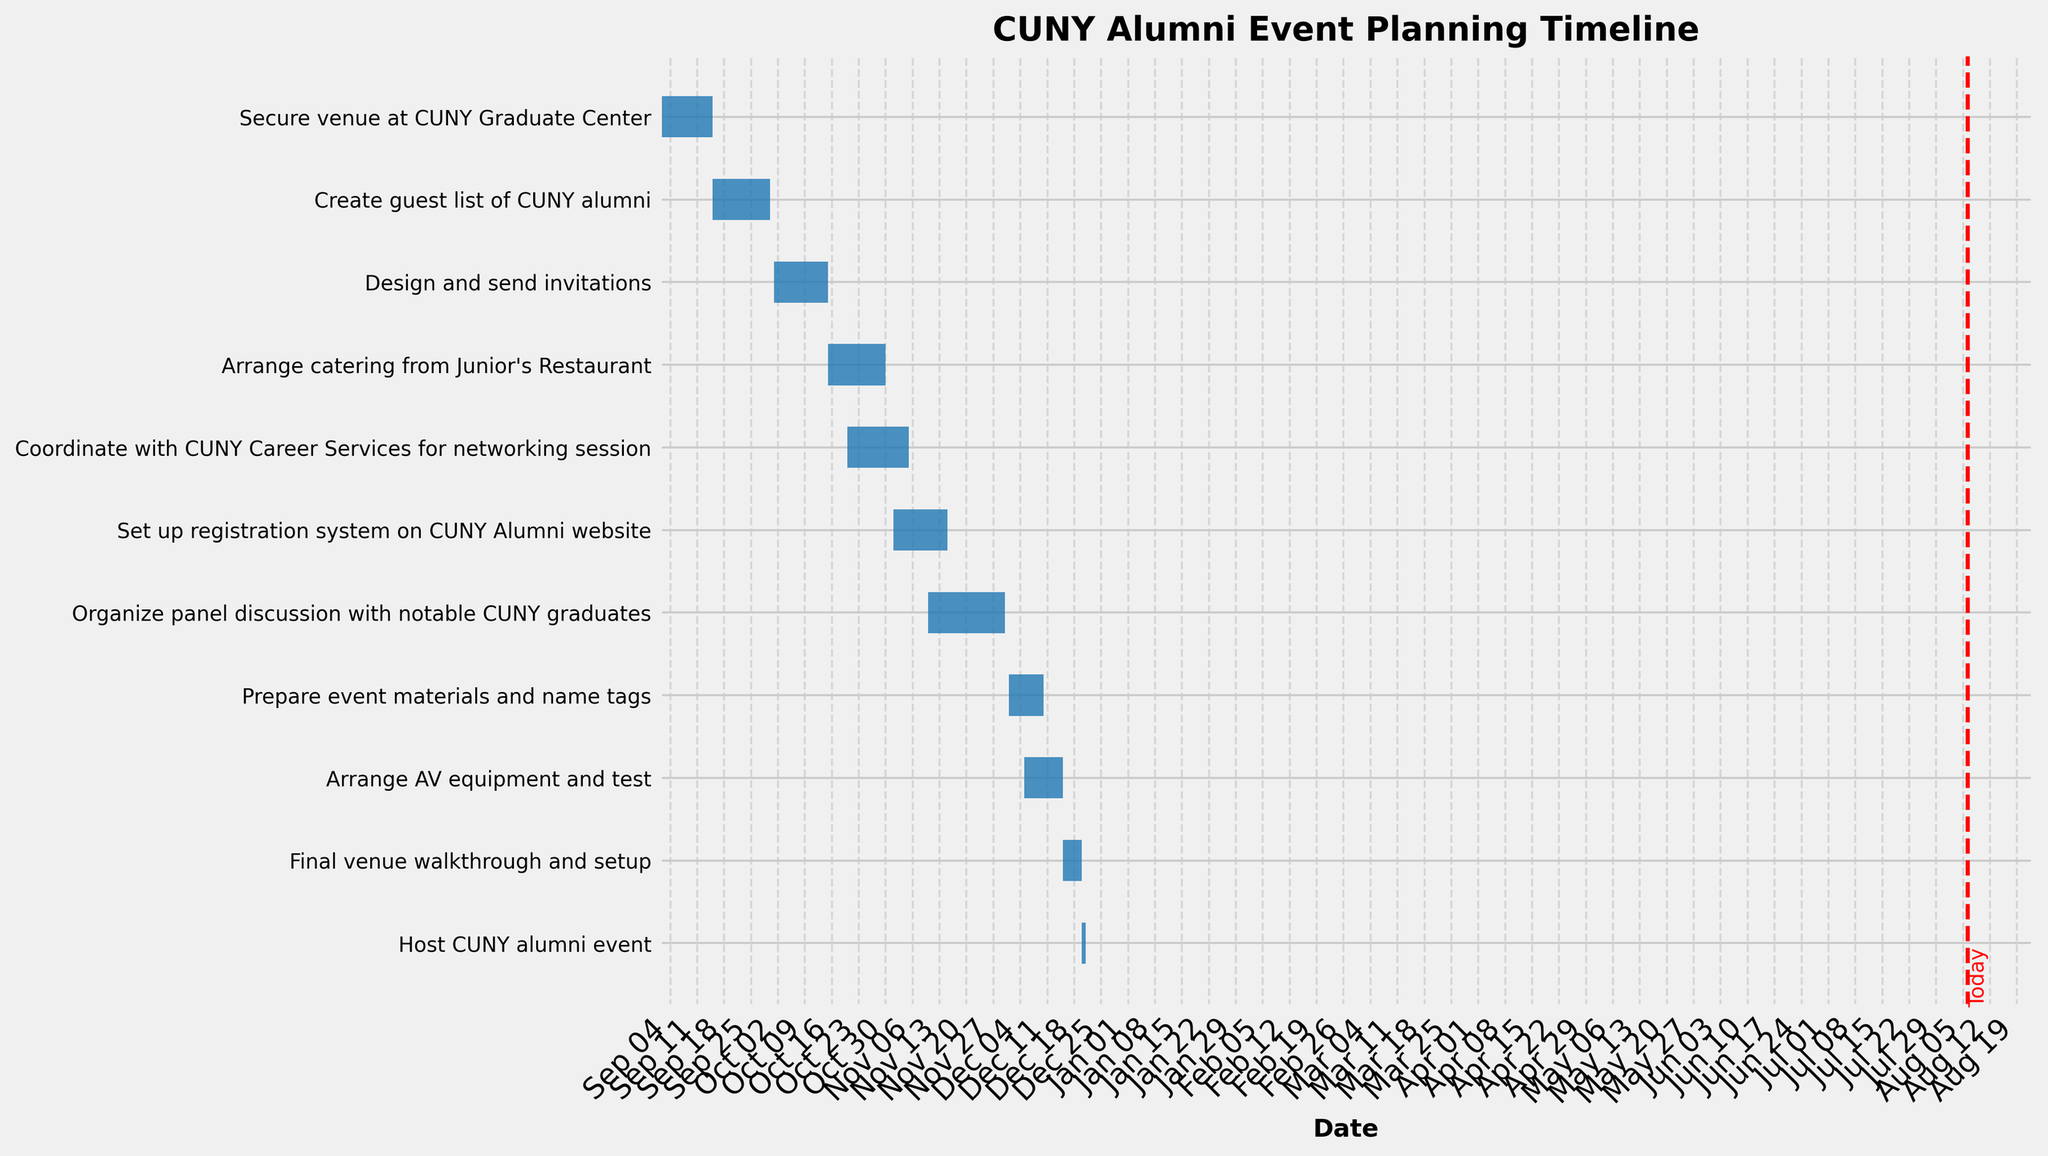What is the title of the Gantt Chart? The title of the Gantt Chart is displayed at the top of the figure.
Answer: CUNY Alumni Event Planning Timeline When does the task 'Secure venue at CUNY Graduate Center' start and end? The task 'Secure venue at CUNY Graduate Center' starts on the left end of its bar at 2023-09-01 and ends on the right end at 2023-09-15.
Answer: 2023-09-01 to 2023-09-15 How many tasks are scheduled to be completed on or before October 30, 2023? Count the tasks whose end dates are on or before October 30, 2023. These are: 'Secure venue at CUNY Graduate Center', 'Create guest list of CUNY alumni', 'Design and send invitations', 'Arrange catering from Junior's Restaurant'.
Answer: 4 Which task has the longest duration, and how long is it? Find the task with the longest bar and check its corresponding duration. The 'Organize panel discussion with notable CUNY graduates' task bar is the longest.
Answer: Organize panel discussion with notable CUNY graduates, 20 days Which task starts the latest? The task that has the latest start date on the x-axis is 'Host CUNY alumni event', starting on 2023-12-20.
Answer: Host CUNY alumni event Are there any tasks that overlap in their timelines? If so, name them. Look for bars that visually overlap along the x-axis. The tasks 'Coordinate with CUNY Career Services for networking session' and 'Set up registration system on CUNY Alumni website' overlap from 2023-11-01 to 2023-11-05. Another overlap occurs between 'Prepare event materials and name tags' and 'Arrange AV equipment and test' from 2023-12-05 to 2023-12-10. Also, 'Arrange AV equipment and test' and 'Final venue walkthrough and setup' overlap from 2023-12-15 to 2023-12-15.
Answer: Yes, 'Coordinate with CUNY Career Services for networking session' with 'Set up registration system on CUNY Alumni website', 'Prepare event materials and name tags' with 'Arrange AV equipment and test', and 'Arrange AV equipment and test' with 'Final venue walkthrough and setup' When is the final venue walkthrough scheduled? The final venue walkthrough bar starts and ends on 2023-12-15 and 2023-12-20.
Answer: 2023-12-15 to 2023-12-20 What is the total number of days allocated for arranging catering from Junior's Restaurant? The duration of arranging catering from Junior's Restaurant is marked directly on the bar as 15 days.
Answer: 15 days Which task directly precedes the task 'Organize panel discussion with notable CUNY graduates'? Observing the Gantt chart, the task immediately before 'Organize panel discussion with notable CUNY graduates' is 'Set up registration system on CUNY Alumni website', which ends right before the start of the panel discussion task.
Answer: Set up registration system on CUNY Alumni website How much time do you have between completing 'Final venue walkthrough and setup' and hosting the event? The 'Final venue walkthrough and setup' ends on 2023-12-20, and the 'Host CUNY alumni event' starts on 2023-12-20. There's no time gap between them.
Answer: No time 